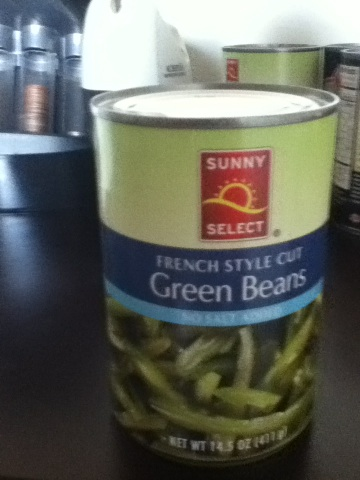Can you tell me about the nutritional value of these green beans? While I cannot provide specific nutritional information without seeing the label, canned green beans typically contain vitamins A, C, and K, along with fiber and minerals like iron and calcium. They are low in calories and can be a healthy part of a balanced diet. 